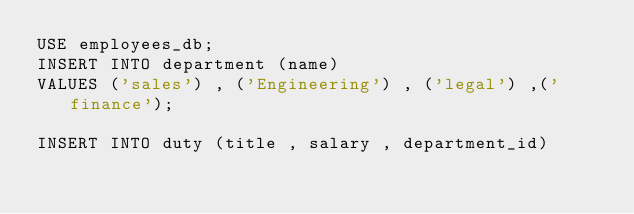Convert code to text. <code><loc_0><loc_0><loc_500><loc_500><_SQL_>USE employees_db;
INSERT INTO department (name)
VALUES ('sales') , ('Engineering') , ('legal') ,('finance');

INSERT INTO duty (title , salary , department_id)</code> 